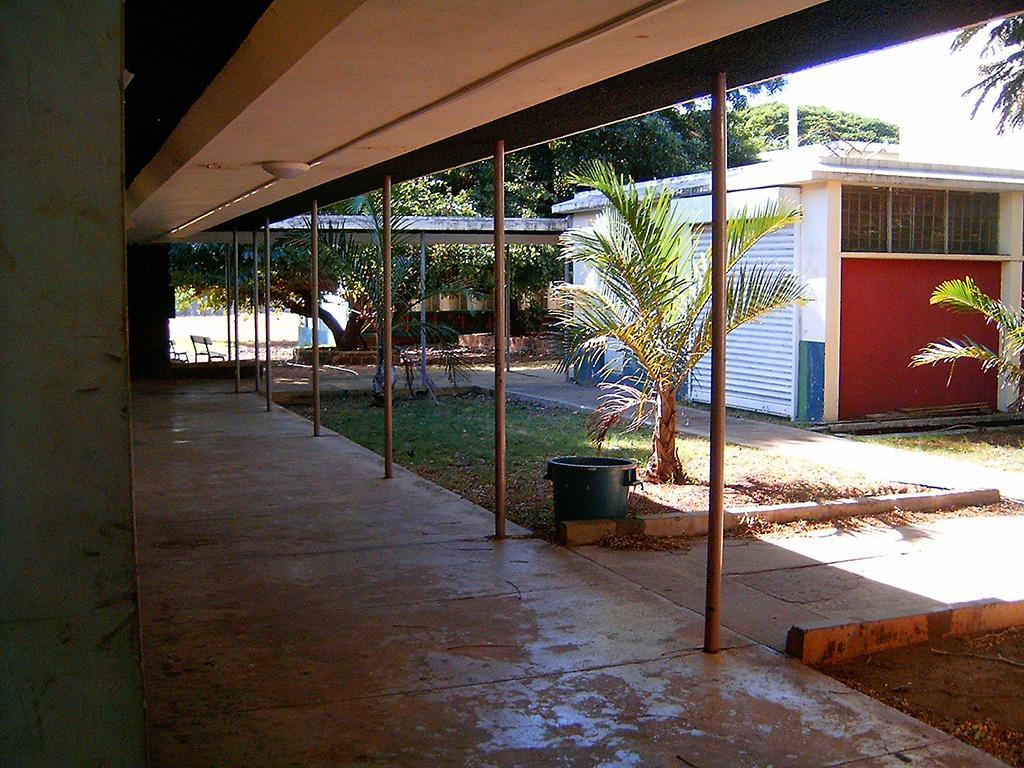Describe this image in one or two sentences. In this image I can see few buildings, shed, poles, trees, chairs, sky and few objects. 